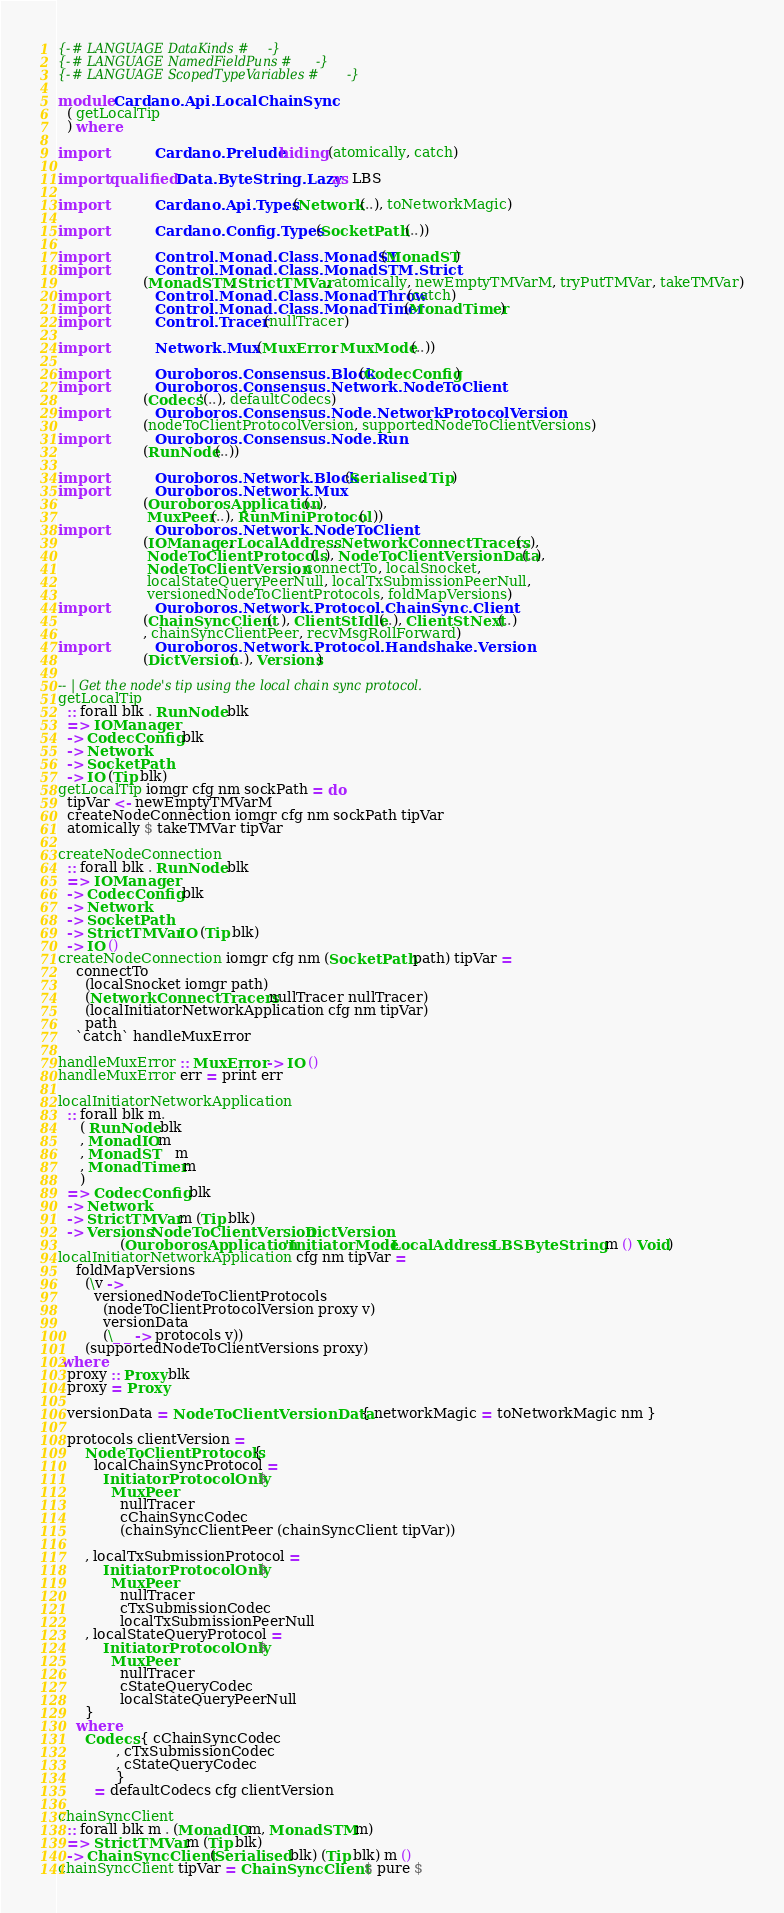<code> <loc_0><loc_0><loc_500><loc_500><_Haskell_>{-# LANGUAGE DataKinds #-}
{-# LANGUAGE NamedFieldPuns #-}
{-# LANGUAGE ScopedTypeVariables #-}

module Cardano.Api.LocalChainSync
  ( getLocalTip
  ) where

import           Cardano.Prelude hiding (atomically, catch)

import qualified Data.ByteString.Lazy as LBS

import           Cardano.Api.Types (Network(..), toNetworkMagic)

import           Cardano.Config.Types (SocketPath (..))

import           Control.Monad.Class.MonadST (MonadST)
import           Control.Monad.Class.MonadSTM.Strict
                   (MonadSTM, StrictTMVar, atomically, newEmptyTMVarM, tryPutTMVar, takeTMVar)
import           Control.Monad.Class.MonadThrow (catch)
import           Control.Monad.Class.MonadTimer (MonadTimer)
import           Control.Tracer (nullTracer)

import           Network.Mux (MuxError, MuxMode(..))

import           Ouroboros.Consensus.Block (CodecConfig)
import           Ouroboros.Consensus.Network.NodeToClient
                   (Codecs'(..), defaultCodecs)
import           Ouroboros.Consensus.Node.NetworkProtocolVersion
                   (nodeToClientProtocolVersion, supportedNodeToClientVersions)
import           Ouroboros.Consensus.Node.Run
                   (RunNode(..))

import           Ouroboros.Network.Block (Serialised, Tip)
import           Ouroboros.Network.Mux
                   (OuroborosApplication(..),
                    MuxPeer(..), RunMiniProtocol(..))
import           Ouroboros.Network.NodeToClient
                   (IOManager, LocalAddress, NetworkConnectTracers(..),
                    NodeToClientProtocols(..), NodeToClientVersionData(..),
                    NodeToClientVersion, connectTo, localSnocket,
                    localStateQueryPeerNull, localTxSubmissionPeerNull,
                    versionedNodeToClientProtocols, foldMapVersions)
import           Ouroboros.Network.Protocol.ChainSync.Client
                   (ChainSyncClient(..), ClientStIdle(..), ClientStNext(..)
                   , chainSyncClientPeer, recvMsgRollForward)
import           Ouroboros.Network.Protocol.Handshake.Version
                   (DictVersion(..), Versions)

-- | Get the node's tip using the local chain sync protocol.
getLocalTip
  :: forall blk . RunNode blk
  => IOManager
  -> CodecConfig blk
  -> Network
  -> SocketPath
  -> IO (Tip blk)
getLocalTip iomgr cfg nm sockPath = do
  tipVar <- newEmptyTMVarM
  createNodeConnection iomgr cfg nm sockPath tipVar
  atomically $ takeTMVar tipVar

createNodeConnection
  :: forall blk . RunNode blk
  => IOManager
  -> CodecConfig blk
  -> Network
  -> SocketPath
  -> StrictTMVar IO (Tip blk)
  -> IO ()
createNodeConnection iomgr cfg nm (SocketPath path) tipVar =
    connectTo
      (localSnocket iomgr path)
      (NetworkConnectTracers nullTracer nullTracer)
      (localInitiatorNetworkApplication cfg nm tipVar)
      path
    `catch` handleMuxError

handleMuxError :: MuxError -> IO ()
handleMuxError err = print err

localInitiatorNetworkApplication
  :: forall blk m.
     ( RunNode blk
     , MonadIO m
     , MonadST    m
     , MonadTimer m
     )
  => CodecConfig blk
  -> Network
  -> StrictTMVar m (Tip blk)
  -> Versions NodeToClientVersion DictVersion
              (OuroborosApplication 'InitiatorMode LocalAddress LBS.ByteString m () Void)
localInitiatorNetworkApplication cfg nm tipVar =
    foldMapVersions
      (\v ->
        versionedNodeToClientProtocols
          (nodeToClientProtocolVersion proxy v)
          versionData
          (\_ _ -> protocols v))
      (supportedNodeToClientVersions proxy)
 where
  proxy :: Proxy blk
  proxy = Proxy

  versionData = NodeToClientVersionData { networkMagic = toNetworkMagic nm }

  protocols clientVersion =
      NodeToClientProtocols {
        localChainSyncProtocol =
          InitiatorProtocolOnly $
            MuxPeer
              nullTracer
              cChainSyncCodec
              (chainSyncClientPeer (chainSyncClient tipVar))

      , localTxSubmissionProtocol =
          InitiatorProtocolOnly $
            MuxPeer
              nullTracer
              cTxSubmissionCodec
              localTxSubmissionPeerNull
      , localStateQueryProtocol =
          InitiatorProtocolOnly $
            MuxPeer
              nullTracer
              cStateQueryCodec
              localStateQueryPeerNull
      }
    where
      Codecs { cChainSyncCodec
             , cTxSubmissionCodec
             , cStateQueryCodec
             }
        = defaultCodecs cfg clientVersion

chainSyncClient
  :: forall blk m . (MonadIO m, MonadSTM m)
  => StrictTMVar m (Tip blk)
  -> ChainSyncClient (Serialised blk) (Tip blk) m ()
chainSyncClient tipVar = ChainSyncClient $ pure $</code> 